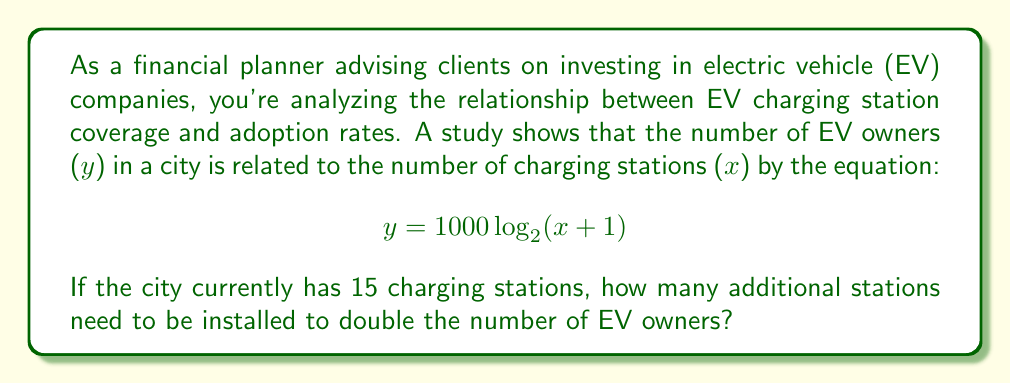Give your solution to this math problem. Let's approach this step-by-step:

1) First, let's calculate the current number of EV owners with 15 charging stations:
   $$ y_1 = 1000 \log_2(15 + 1) = 1000 \log_2(16) = 1000 \cdot 4 = 4000 $$

2) To double the number of EV owners, we need to find x when y = 8000:
   $$ 8000 = 1000 \log_2(x + 1) $$

3) Divide both sides by 1000:
   $$ 8 = \log_2(x + 1) $$

4) Apply $2^x$ to both sides:
   $$ 2^8 = x + 1 $$

5) Solve for x:
   $$ 256 = x + 1 $$
   $$ x = 255 $$

6) The question asks for additional stations, so we need to subtract the original 15:
   $$ 255 - 15 = 240 $$

Therefore, 240 additional charging stations need to be installed to double the number of EV owners.
Answer: 240 additional charging stations 